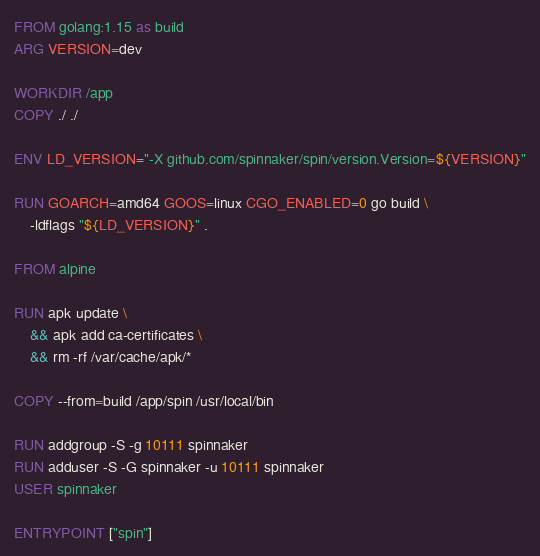Convert code to text. <code><loc_0><loc_0><loc_500><loc_500><_Dockerfile_>FROM golang:1.15 as build
ARG VERSION=dev

WORKDIR /app
COPY ./ ./

ENV LD_VERSION="-X github.com/spinnaker/spin/version.Version=${VERSION}"

RUN GOARCH=amd64 GOOS=linux CGO_ENABLED=0 go build \
    -ldflags "${LD_VERSION}" .

FROM alpine

RUN apk update \
    && apk add ca-certificates \
    && rm -rf /var/cache/apk/*

COPY --from=build /app/spin /usr/local/bin

RUN addgroup -S -g 10111 spinnaker
RUN adduser -S -G spinnaker -u 10111 spinnaker
USER spinnaker

ENTRYPOINT ["spin"]
</code> 